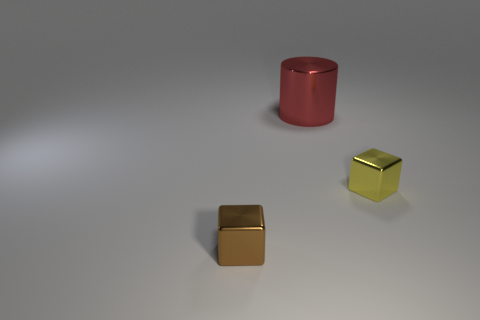Does the small brown metal thing have the same shape as the small yellow thing?
Offer a very short reply. Yes. Is there any other thing that is the same color as the large thing?
Give a very brief answer. No. The metal thing that is both to the left of the yellow thing and in front of the cylinder has what shape?
Give a very brief answer. Cube. Are there an equal number of tiny brown objects right of the large cylinder and things right of the brown metallic block?
Your response must be concise. No. What number of cylinders are either large things or large rubber things?
Offer a very short reply. 1. What number of tiny objects have the same material as the cylinder?
Ensure brevity in your answer.  2. What is the object that is left of the small yellow metal cube and in front of the large metal thing made of?
Make the answer very short. Metal. The tiny brown object that is to the left of the large thing has what shape?
Your answer should be compact. Cube. What shape is the object that is behind the tiny metal block right of the big red shiny object?
Your answer should be very brief. Cylinder. Is there another blue matte object that has the same shape as the large object?
Ensure brevity in your answer.  No. 